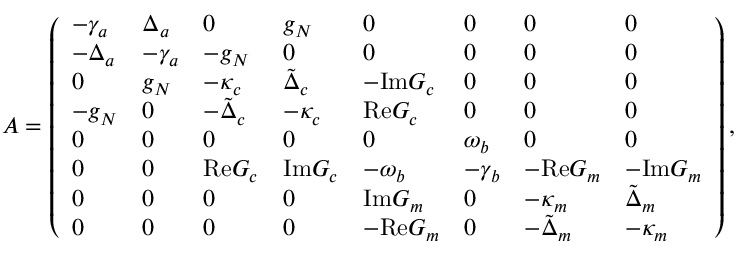<formula> <loc_0><loc_0><loc_500><loc_500>A = \left ( \begin{array} { l l l l l l l l } { - \gamma _ { a } } & { \Delta _ { a } } & { 0 } & { g _ { N } } & { 0 } & { 0 } & { 0 } & { 0 } \\ { - \Delta _ { a } } & { - \gamma _ { a } } & { - g _ { N } } & { 0 } & { 0 } & { 0 } & { 0 } & { 0 } \\ { 0 } & { g _ { N } } & { - \kappa _ { c } } & { \tilde { \Delta } _ { c } } & { - I m G _ { c } } & { 0 } & { 0 } & { 0 } \\ { - g _ { N } } & { 0 } & { - \tilde { \Delta } _ { c } } & { - \kappa _ { c } } & { R e G _ { c } } & { 0 } & { 0 } & { 0 } \\ { 0 } & { 0 } & { 0 } & { 0 } & { 0 } & { \omega _ { b } } & { 0 } & { 0 } \\ { 0 } & { 0 } & { R e G _ { c } } & { I m G _ { c } } & { - \omega _ { b } } & { - \gamma _ { b } } & { - R e G _ { m } } & { - I m G _ { m } } \\ { 0 } & { 0 } & { 0 } & { 0 } & { I m G _ { m } } & { 0 } & { - \kappa _ { m } } & { \tilde { \Delta } _ { m } } \\ { 0 } & { 0 } & { 0 } & { 0 } & { - R e G _ { m } } & { 0 } & { - \tilde { \Delta } _ { m } } & { - \kappa _ { m } } \end{array} \right ) ,</formula> 